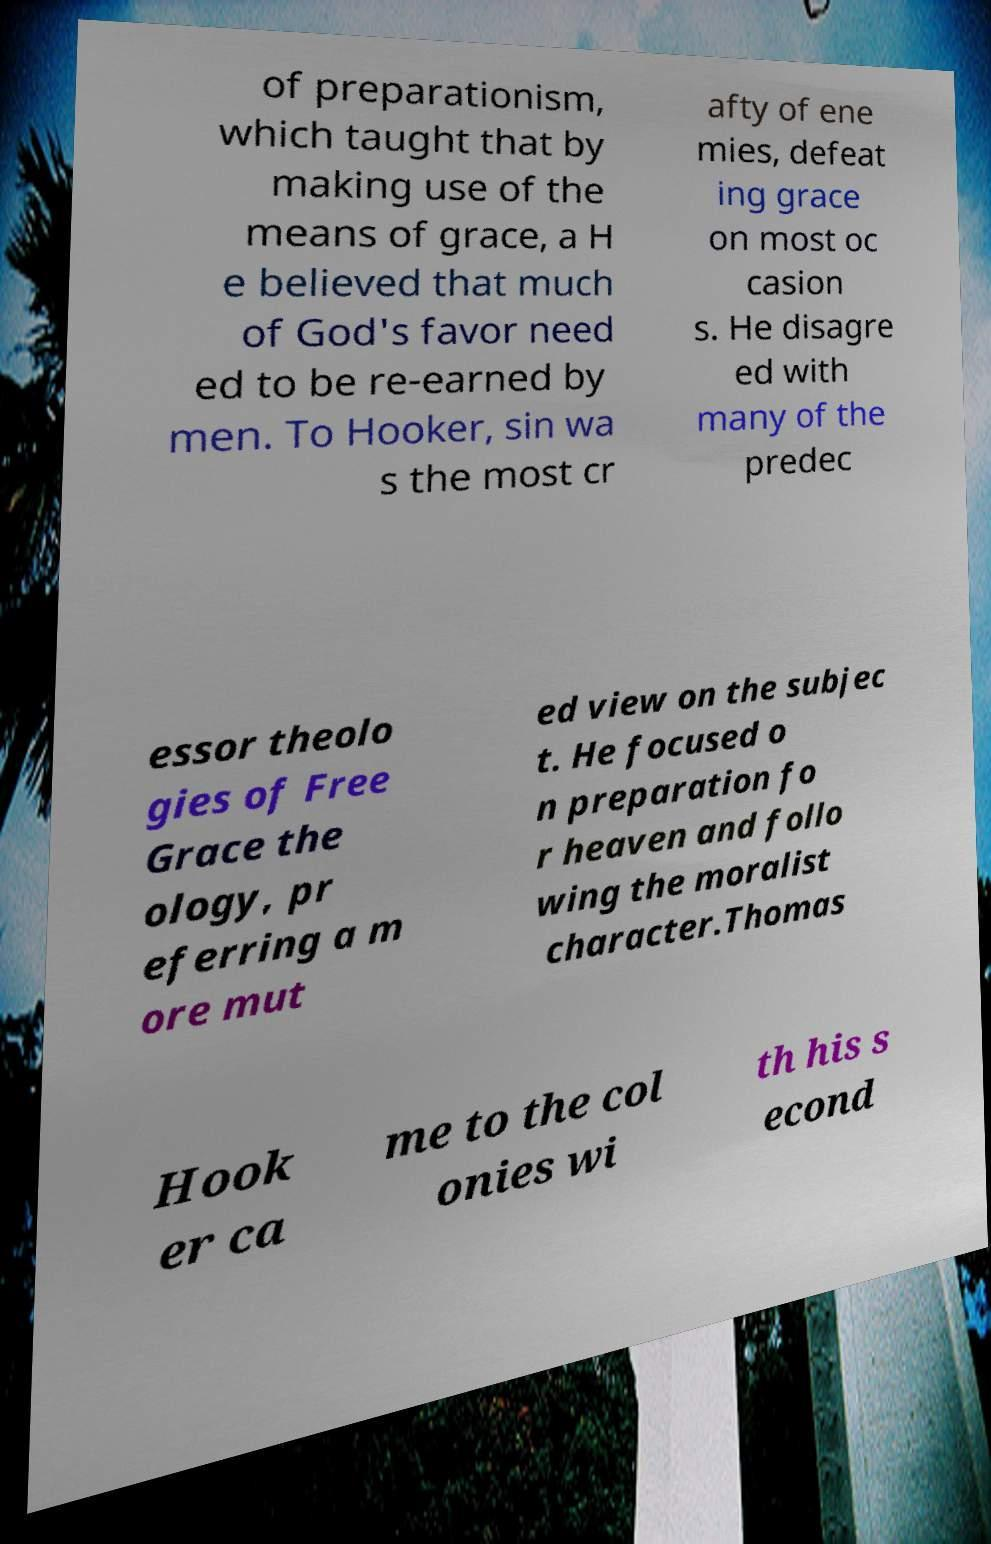What messages or text are displayed in this image? I need them in a readable, typed format. of preparationism, which taught that by making use of the means of grace, a H e believed that much of God's favor need ed to be re-earned by men. To Hooker, sin wa s the most cr afty of ene mies, defeat ing grace on most oc casion s. He disagre ed with many of the predec essor theolo gies of Free Grace the ology, pr eferring a m ore mut ed view on the subjec t. He focused o n preparation fo r heaven and follo wing the moralist character.Thomas Hook er ca me to the col onies wi th his s econd 